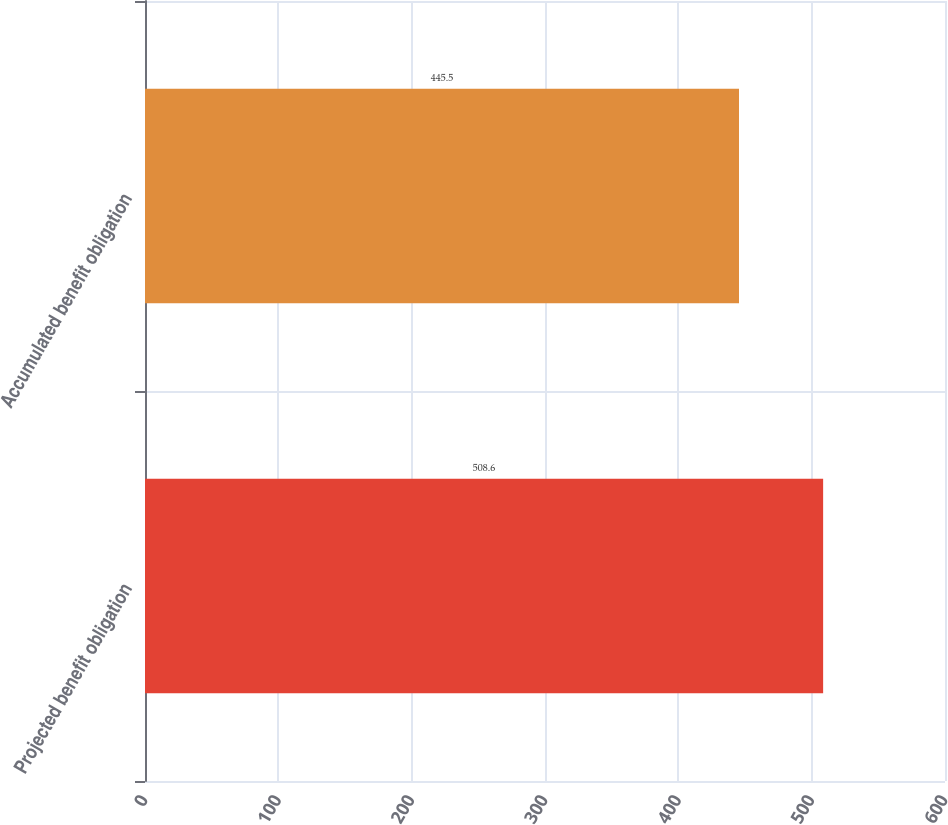Convert chart to OTSL. <chart><loc_0><loc_0><loc_500><loc_500><bar_chart><fcel>Projected benefit obligation<fcel>Accumulated benefit obligation<nl><fcel>508.6<fcel>445.5<nl></chart> 